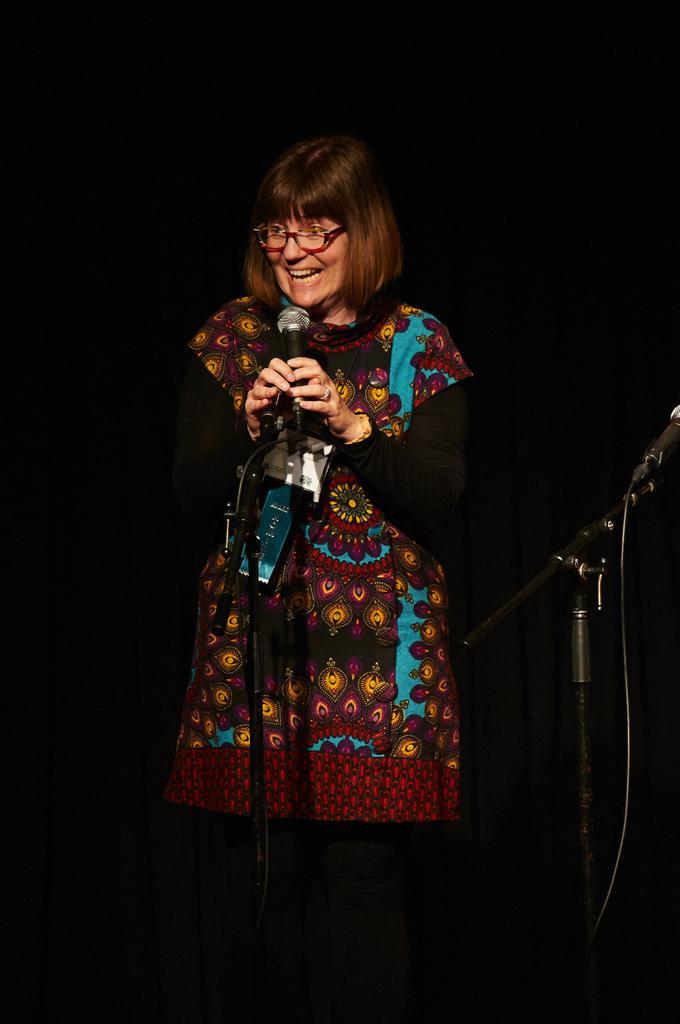In one or two sentences, can you explain what this image depicts? In this image I can see a person and the person is holding a microphone. The person is wearing brown and blue color dress and I can see dark background. 